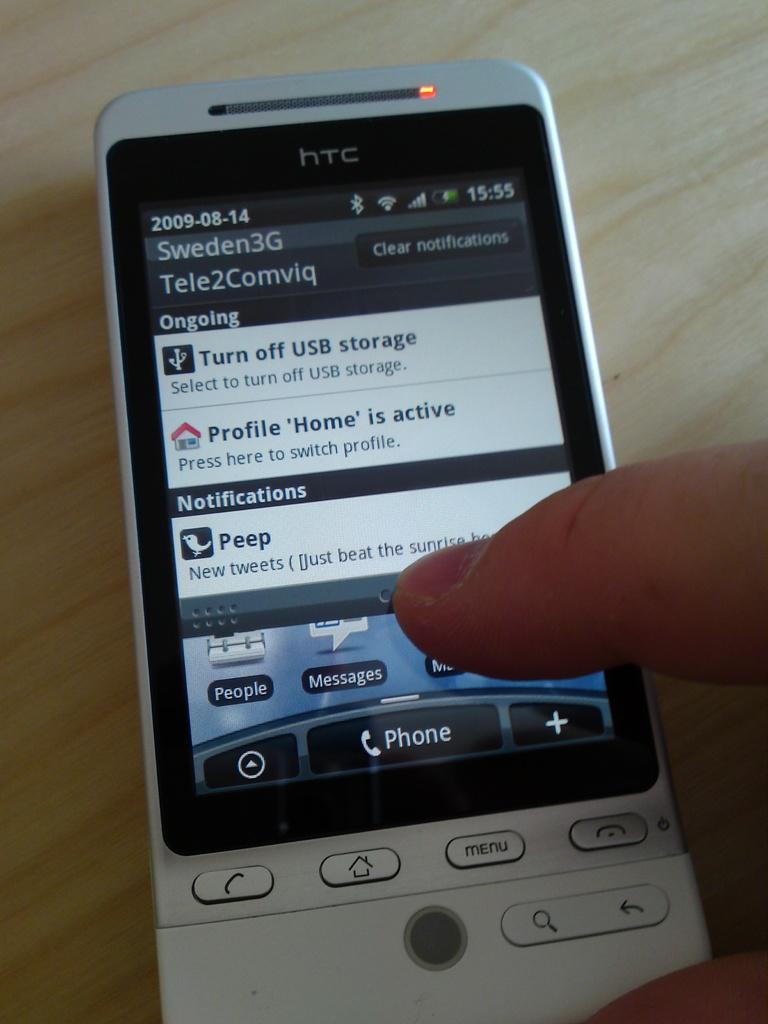<image>
Share a concise interpretation of the image provided. A gray and black HTC cell phone with a finger pointed on the screen. 